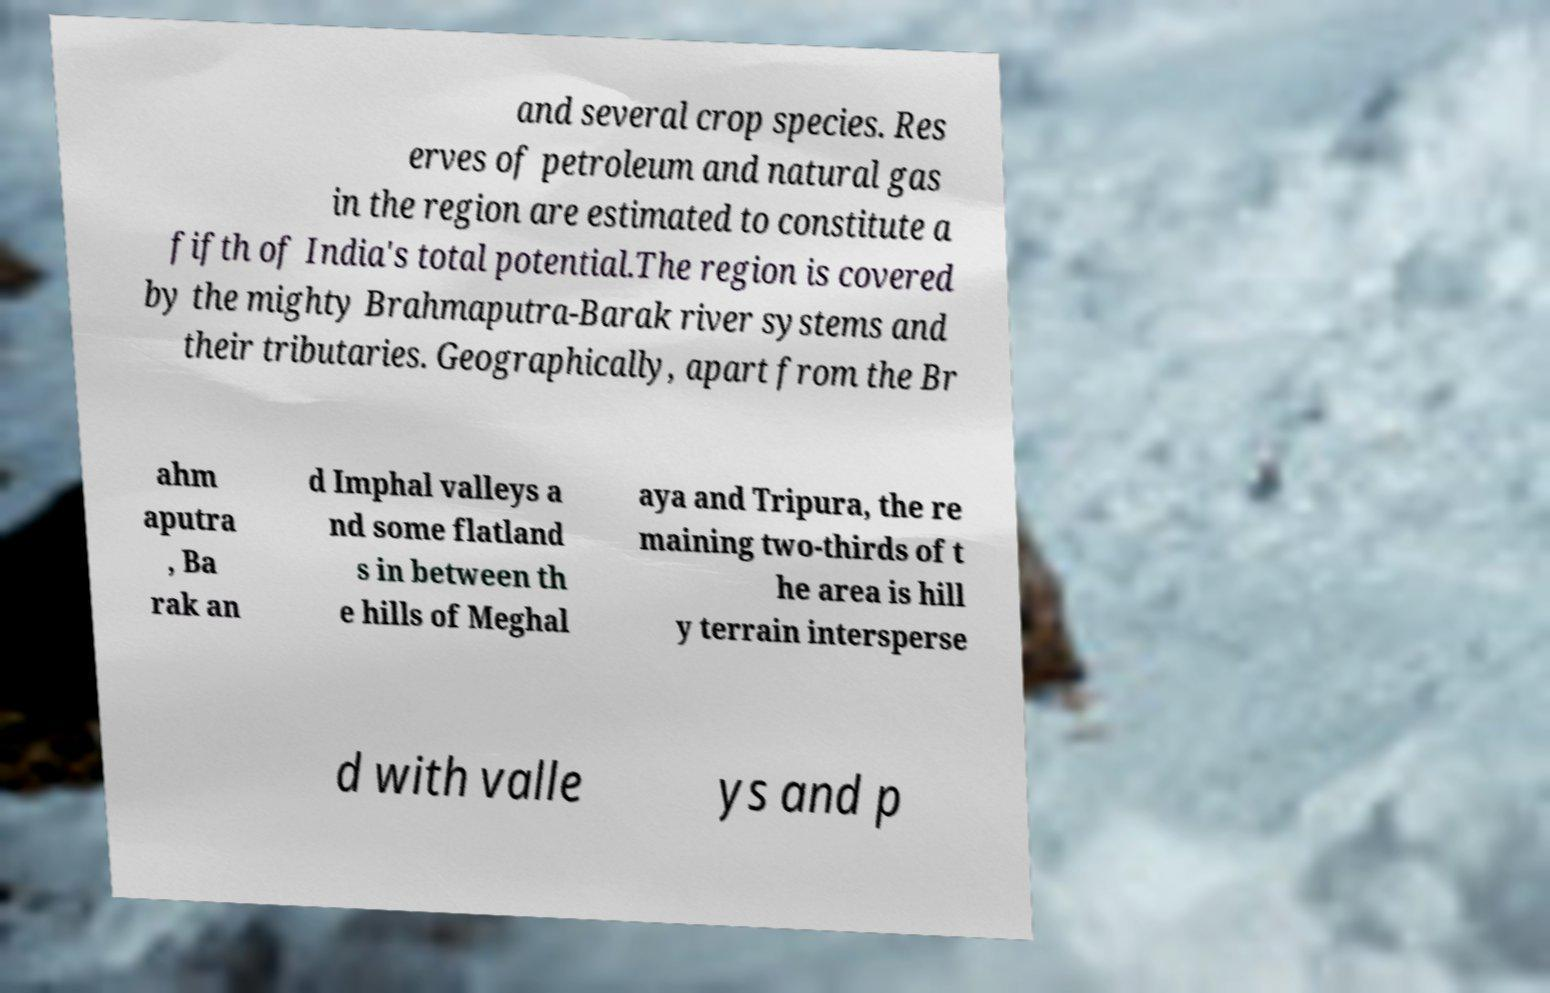Could you extract and type out the text from this image? and several crop species. Res erves of petroleum and natural gas in the region are estimated to constitute a fifth of India's total potential.The region is covered by the mighty Brahmaputra-Barak river systems and their tributaries. Geographically, apart from the Br ahm aputra , Ba rak an d Imphal valleys a nd some flatland s in between th e hills of Meghal aya and Tripura, the re maining two-thirds of t he area is hill y terrain intersperse d with valle ys and p 